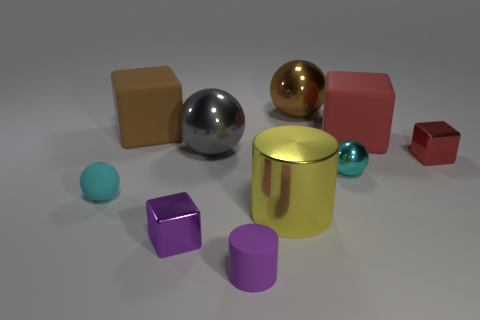Subtract all purple shiny blocks. How many blocks are left? 3 Subtract all purple cubes. How many cubes are left? 3 Subtract 2 balls. How many balls are left? 2 Subtract 0 blue cylinders. How many objects are left? 10 Subtract all blocks. How many objects are left? 6 Subtract all yellow spheres. Subtract all cyan cylinders. How many spheres are left? 4 Subtract all purple cylinders. How many purple balls are left? 0 Subtract all tiny cubes. Subtract all large yellow metal cylinders. How many objects are left? 7 Add 9 purple metallic blocks. How many purple metallic blocks are left? 10 Add 8 big yellow shiny cylinders. How many big yellow shiny cylinders exist? 9 